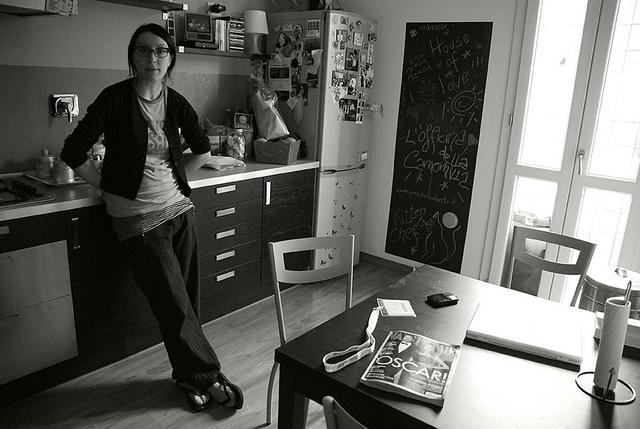Excellence in the American and International film industry award is what? oscar 